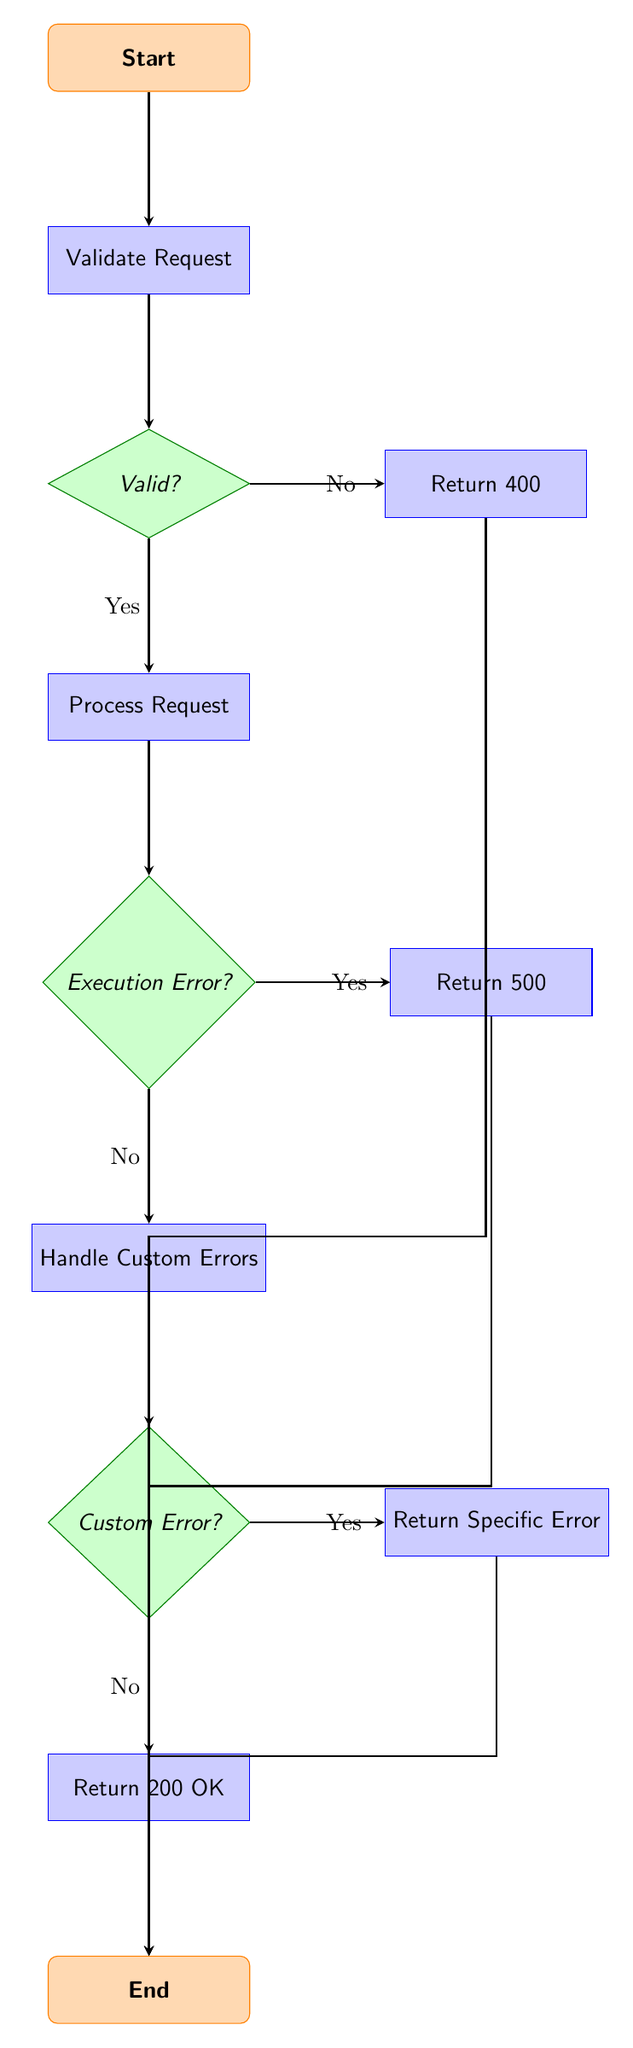What is the first step in the error handling flow? The first step in the error handling flow is the initiation of a request by the user. It is indicated in the diagram as the "Start" node.
Answer: User initiates a request to the web application How many decision nodes are in the diagram? The diagram contains three decision nodes: "Is the request valid?", "Did an execution error occur?", and "Did a custom error occur?".
Answer: Three What happens if the request is invalid? If the request is invalid, the flow directs to the node that returns a 400 Bad Request error. This is shown with a "No" branch from the validation decision node.
Answer: Return 400 Bad Request error What process is executed after validating the request and confirming it's valid? After confirming the request is valid, the next step in the flow is to process the valid request, as indicated by the "Yes" branch from the validation decision node.
Answer: Process the valid request What does the flow do if an execution error occurs? If an execution error occurs, it leads to returning a 500 Internal Server Error as represented by the "Yes" branch of the execution error decision node.
Answer: Return 500 Internal Server Error If there is no execution error, what step follows? If there is no execution error, the flow proceeds to handle custom application errors, shown by the "No" branch from the execution error decision node.
Answer: Handle custom application errors What is the final step in the error handling flow? The final step in the error handling flow is the "End" node, indicating the conclusion of the error handling process.
Answer: End of error handling flow What type of error is returned if a custom error occurs? If a custom error occurs, a specific error message based on the custom error type is returned, which is indicated by the "Yes" branch of the custom error decision node.
Answer: Return a specific error message based on the custom error type What does the flow return if no errors occur during the process? If no errors occur, the flow will return a 200 OK along with the processed results, as shown by the "No" branch of the custom error decision node.
Answer: Return 200 OK and process results 